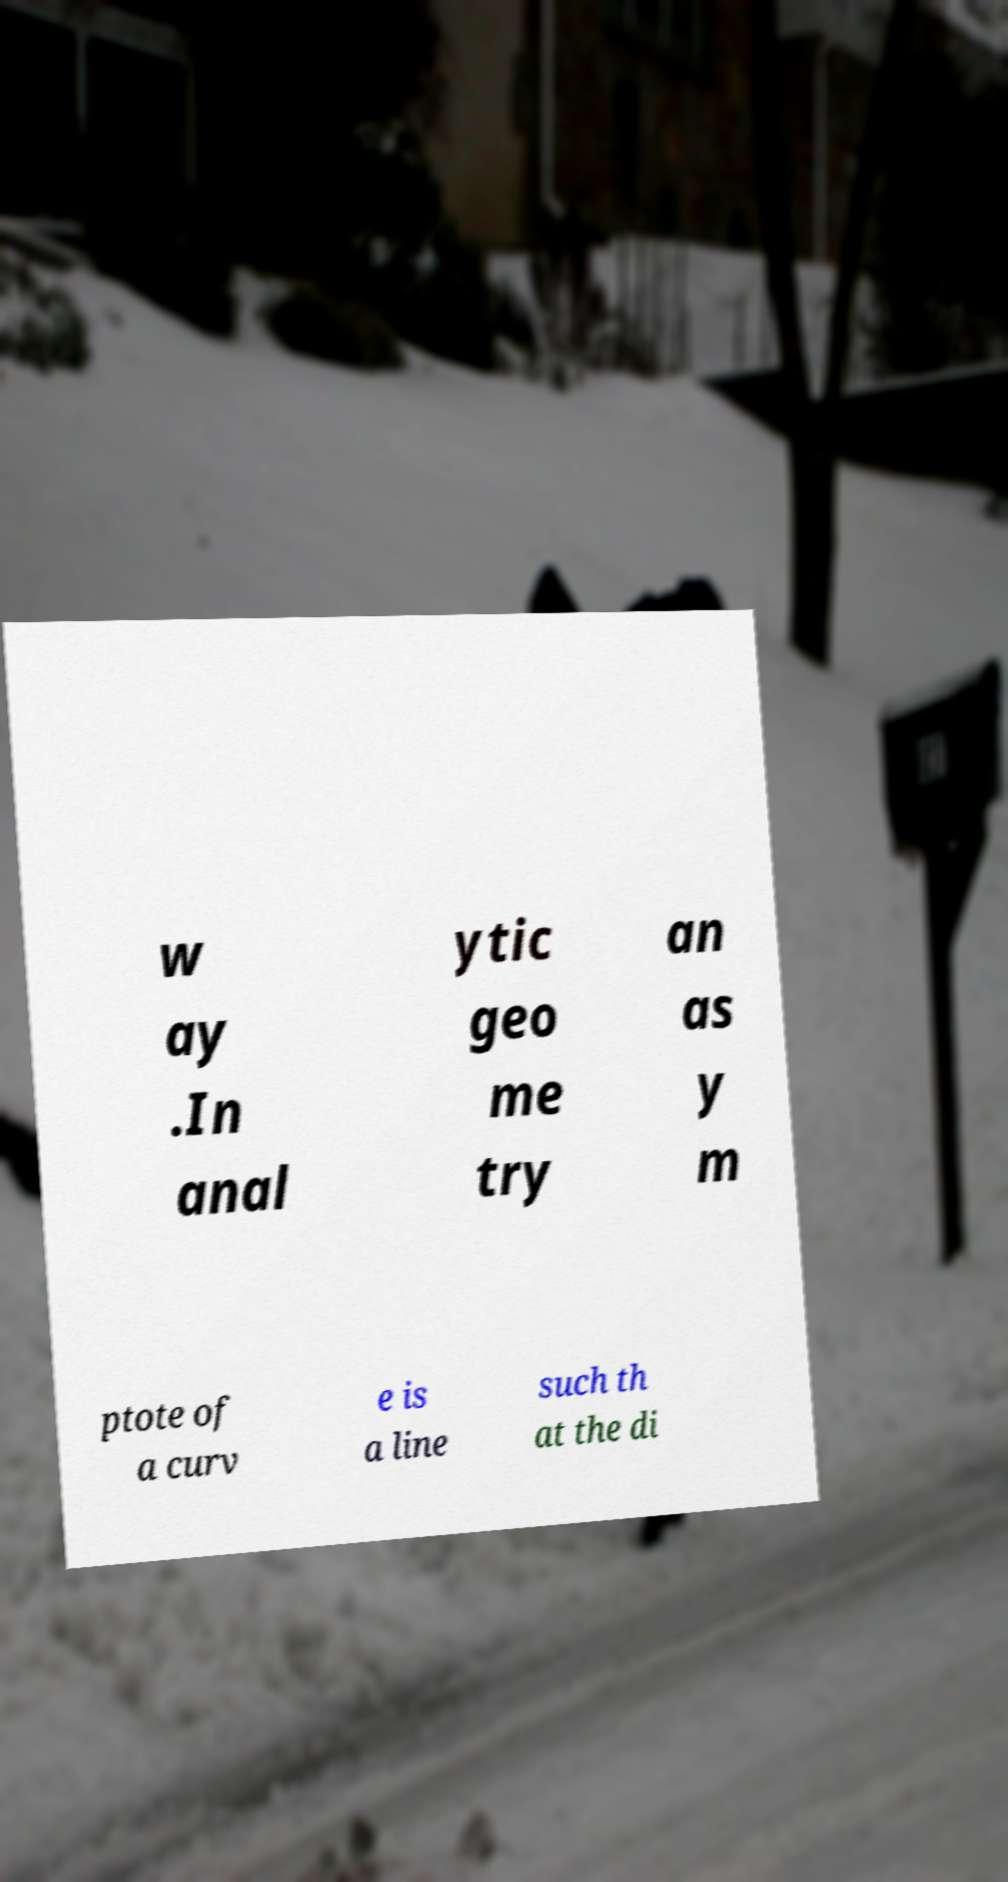There's text embedded in this image that I need extracted. Can you transcribe it verbatim? w ay .In anal ytic geo me try an as y m ptote of a curv e is a line such th at the di 